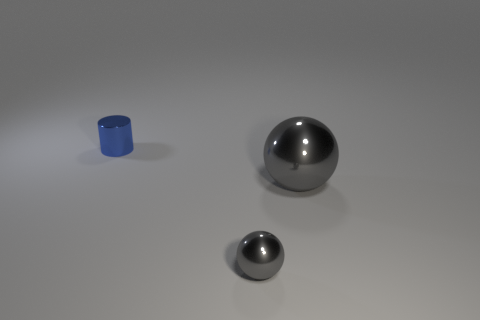What number of blue objects are the same size as the metal cylinder?
Make the answer very short. 0. What size is the metal object that is the same color as the large sphere?
Provide a succinct answer. Small. How many tiny things are spheres or cylinders?
Give a very brief answer. 2. How many small cylinders are there?
Make the answer very short. 1. Is the number of tiny gray spheres behind the blue metal thing the same as the number of metal balls that are on the right side of the large gray metal thing?
Your response must be concise. Yes. There is a small cylinder; are there any large spheres right of it?
Give a very brief answer. Yes. What is the color of the metal thing in front of the big gray shiny ball?
Ensure brevity in your answer.  Gray. The gray ball behind the sphere in front of the big shiny object is made of what material?
Your response must be concise. Metal. Are there fewer big shiny balls right of the blue object than shiny objects behind the tiny metal ball?
Your answer should be compact. Yes. What number of purple objects are either metallic objects or large spheres?
Ensure brevity in your answer.  0. 